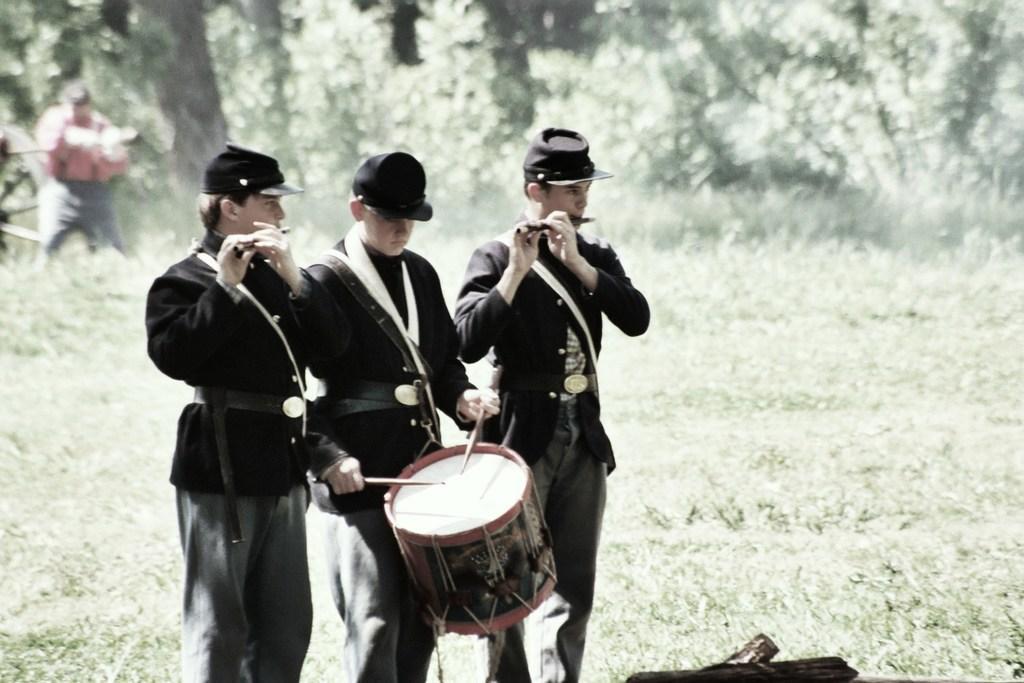Can you describe this image briefly? In this image i can see there are three men who are playing musical instruments. 